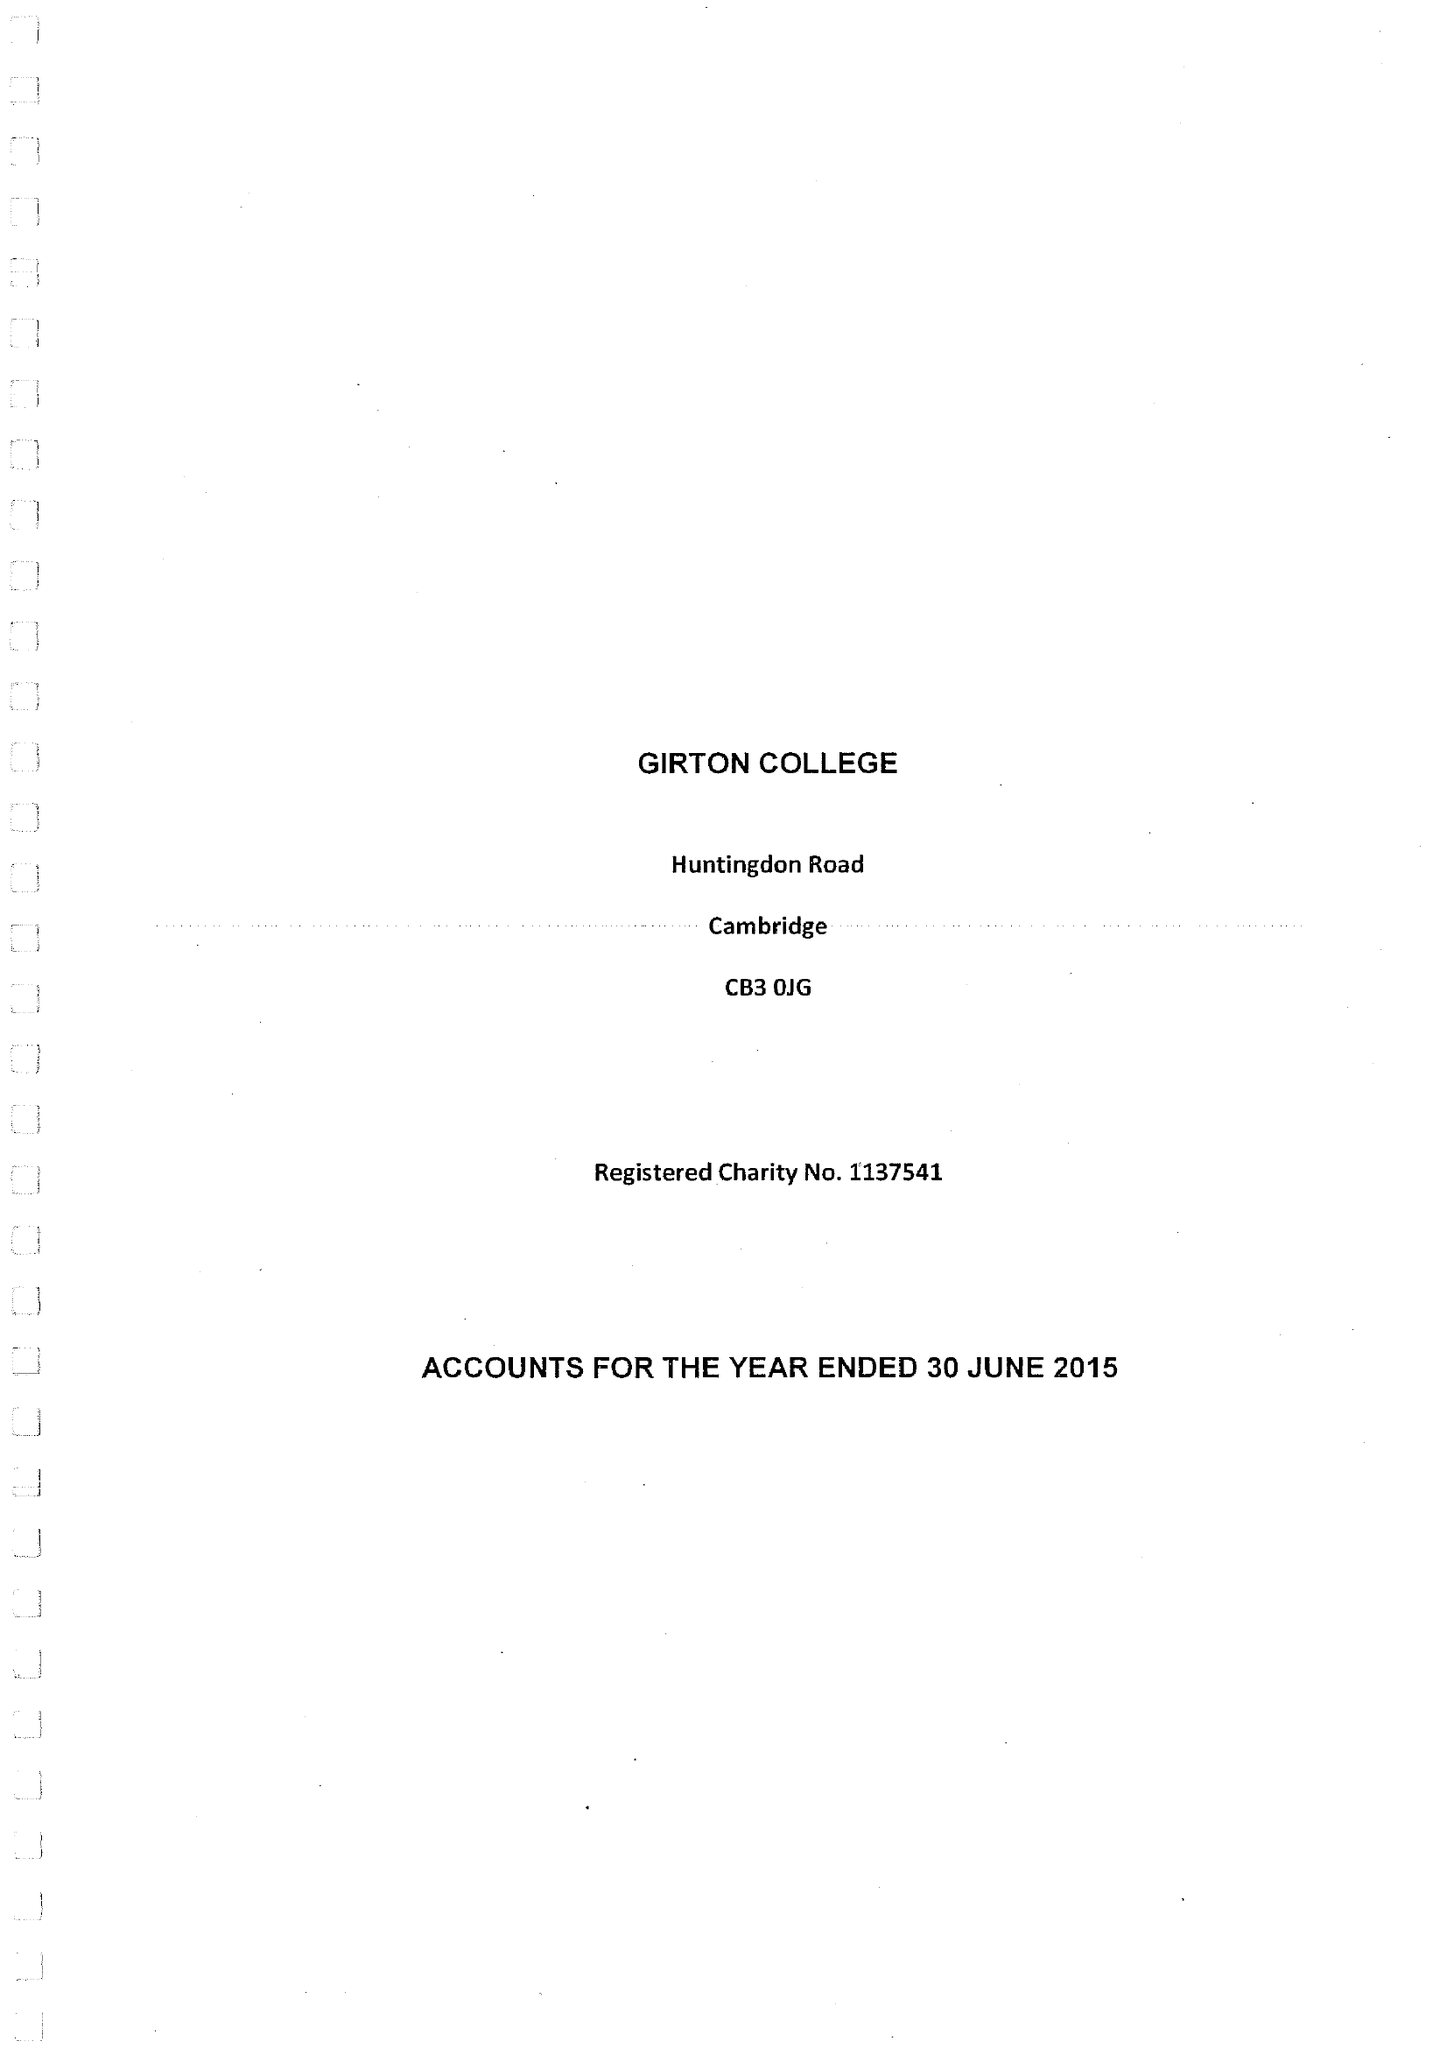What is the value for the charity_number?
Answer the question using a single word or phrase. 1137541 